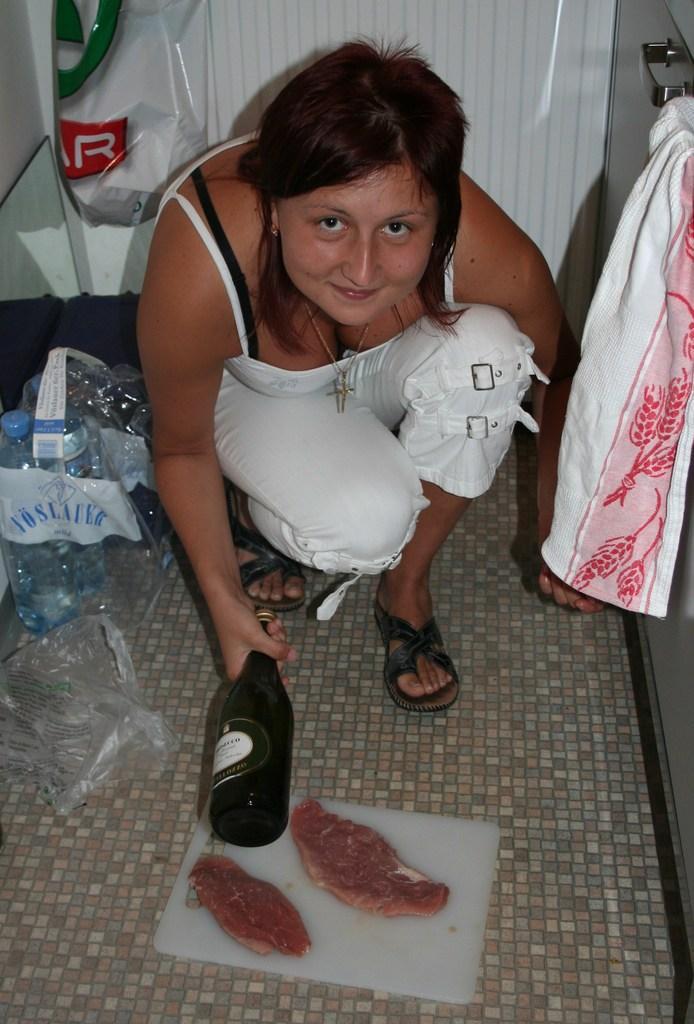Describe this image in one or two sentences. In this image, we can see a woman, she is holding a black color wine bottle, there is a white color chopping board on that there are two objects placed, at the left side there are some bottles kept in a cover. 